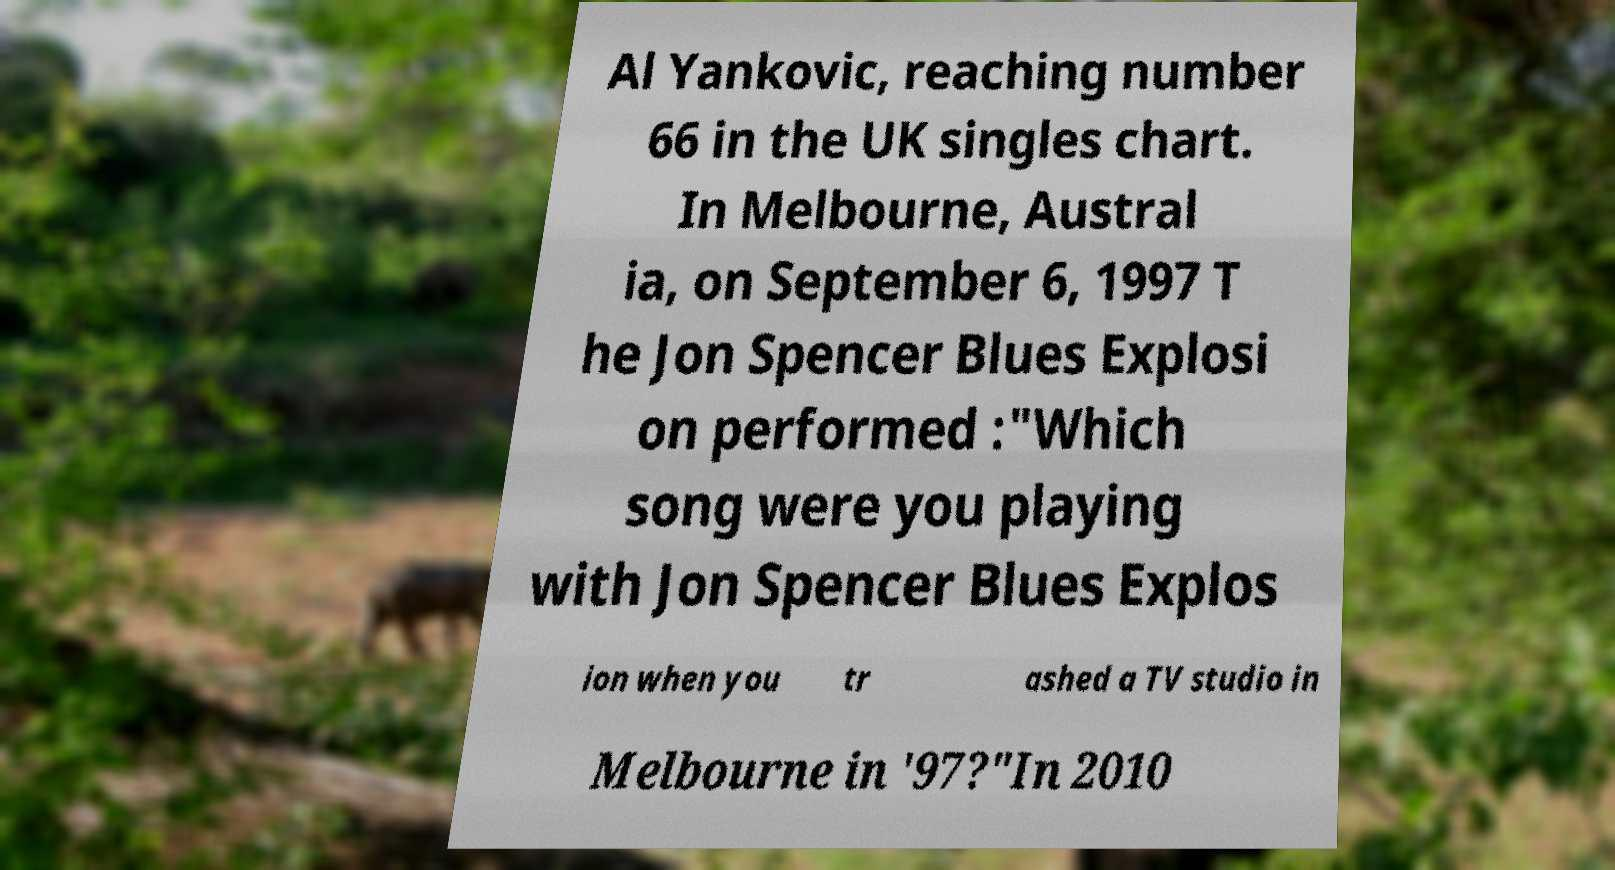What messages or text are displayed in this image? I need them in a readable, typed format. Al Yankovic, reaching number 66 in the UK singles chart. In Melbourne, Austral ia, on September 6, 1997 T he Jon Spencer Blues Explosi on performed :"Which song were you playing with Jon Spencer Blues Explos ion when you tr ashed a TV studio in Melbourne in '97?"In 2010 